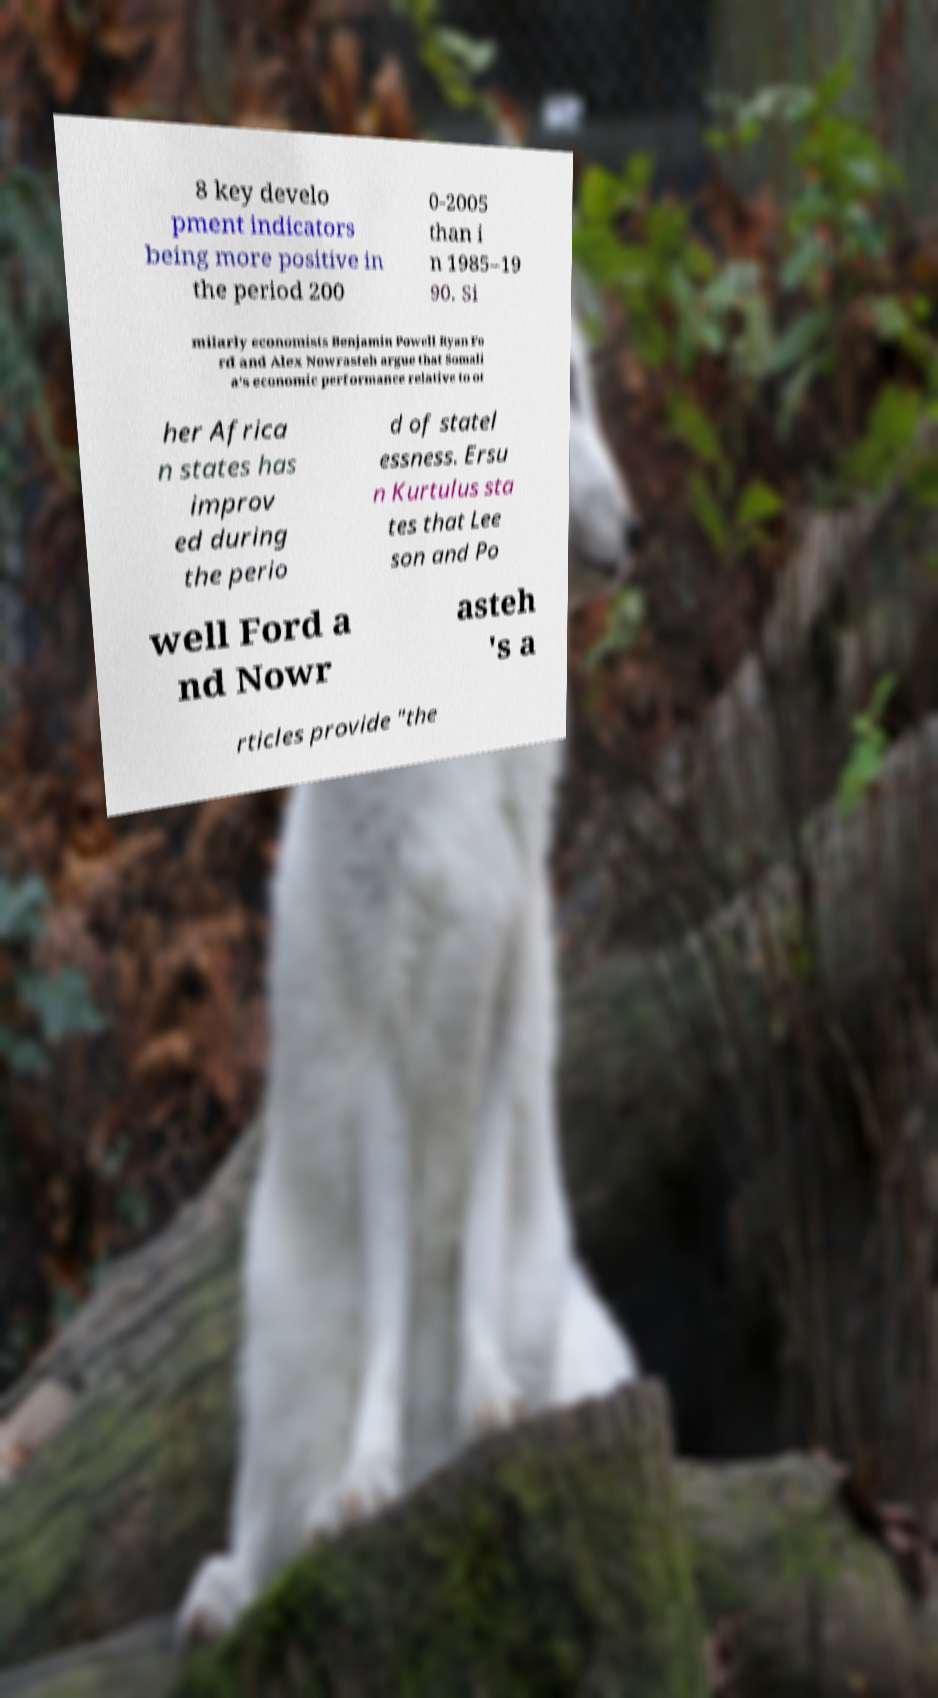What messages or text are displayed in this image? I need them in a readable, typed format. 8 key develo pment indicators being more positive in the period 200 0-2005 than i n 1985–19 90. Si milarly economists Benjamin Powell Ryan Fo rd and Alex Nowrasteh argue that Somali a's economic performance relative to ot her Africa n states has improv ed during the perio d of statel essness. Ersu n Kurtulus sta tes that Lee son and Po well Ford a nd Nowr asteh 's a rticles provide "the 